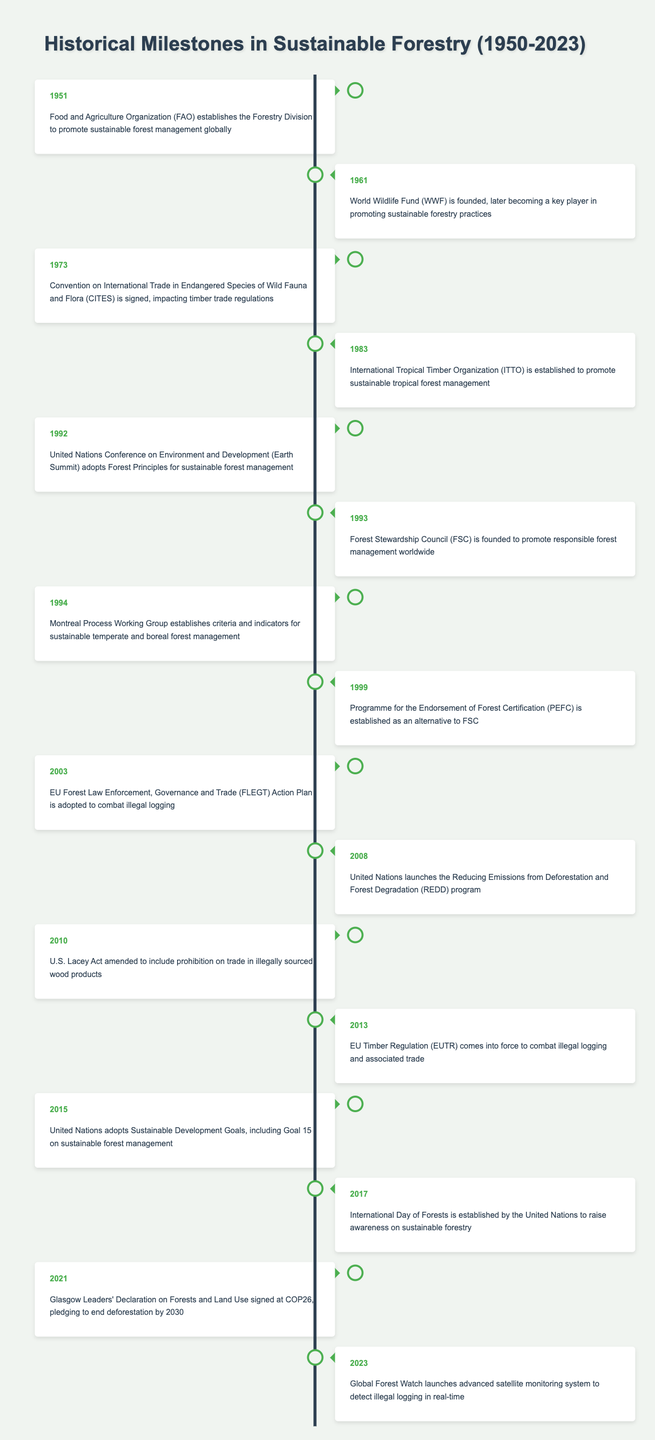What year was the Food and Agriculture Organization's Forestry Division established? The table lists the event that states the FAO established the Forestry Division in 1951, so the year is clearly indicated in the entry.
Answer: 1951 Which organization was founded in 1993 to promote responsible forest management? The table indicates that the Forest Stewardship Council (FSC) was founded in 1993 specifically for the purpose of promoting responsible forest management worldwide.
Answer: Forest Stewardship Council (FSC) How many significant milestones are recorded between 2000 and 2020? The milestones from the table between the years 2000 and 2020 include 2003, 2008, 2010, 2013, 2015, 2017, and 2021. Counting these gives a total of 6 significant milestones within that range.
Answer: 6 Is the establishment of the International Tropical Timber Organization listed before the adoption of the Forest Principles? The International Tropical Timber Organization was established in 1983, and the Forest Principles were adopted in 1992. Since 1983 is earlier than 1992, the statement is true.
Answer: Yes What is the difference in years between the founding of the World Wildlife Fund and the EU Timber Regulation? The World Wildlife Fund was founded in 1961 and the EU Timber Regulation came into force in 2013. The difference can be calculated by subtracting 1961 from 2013, which gives 52 years.
Answer: 52 What event occurred first, the signing of CITES or the establishment of the United Nations Reducing Emissions program? CITES was signed in 1973, while the UN launched the REDD program in 2008. Since 1973 is before 2008, the event of signing CITES occurred first.
Answer: CITES Which event concerning illegal logging occurred in 2003? The table shows that in 2003, the EU Forest Law Enforcement, Governance and Trade Action Plan was adopted to combat illegal logging.
Answer: EU FLEGT Action Plan adopted What year marks the launch of the advanced satellite monitoring system by Global Forest Watch? According to the last entry in the table, Global Forest Watch launched the satellite monitoring system in 2023, which is simply stated in the event description.
Answer: 2023 